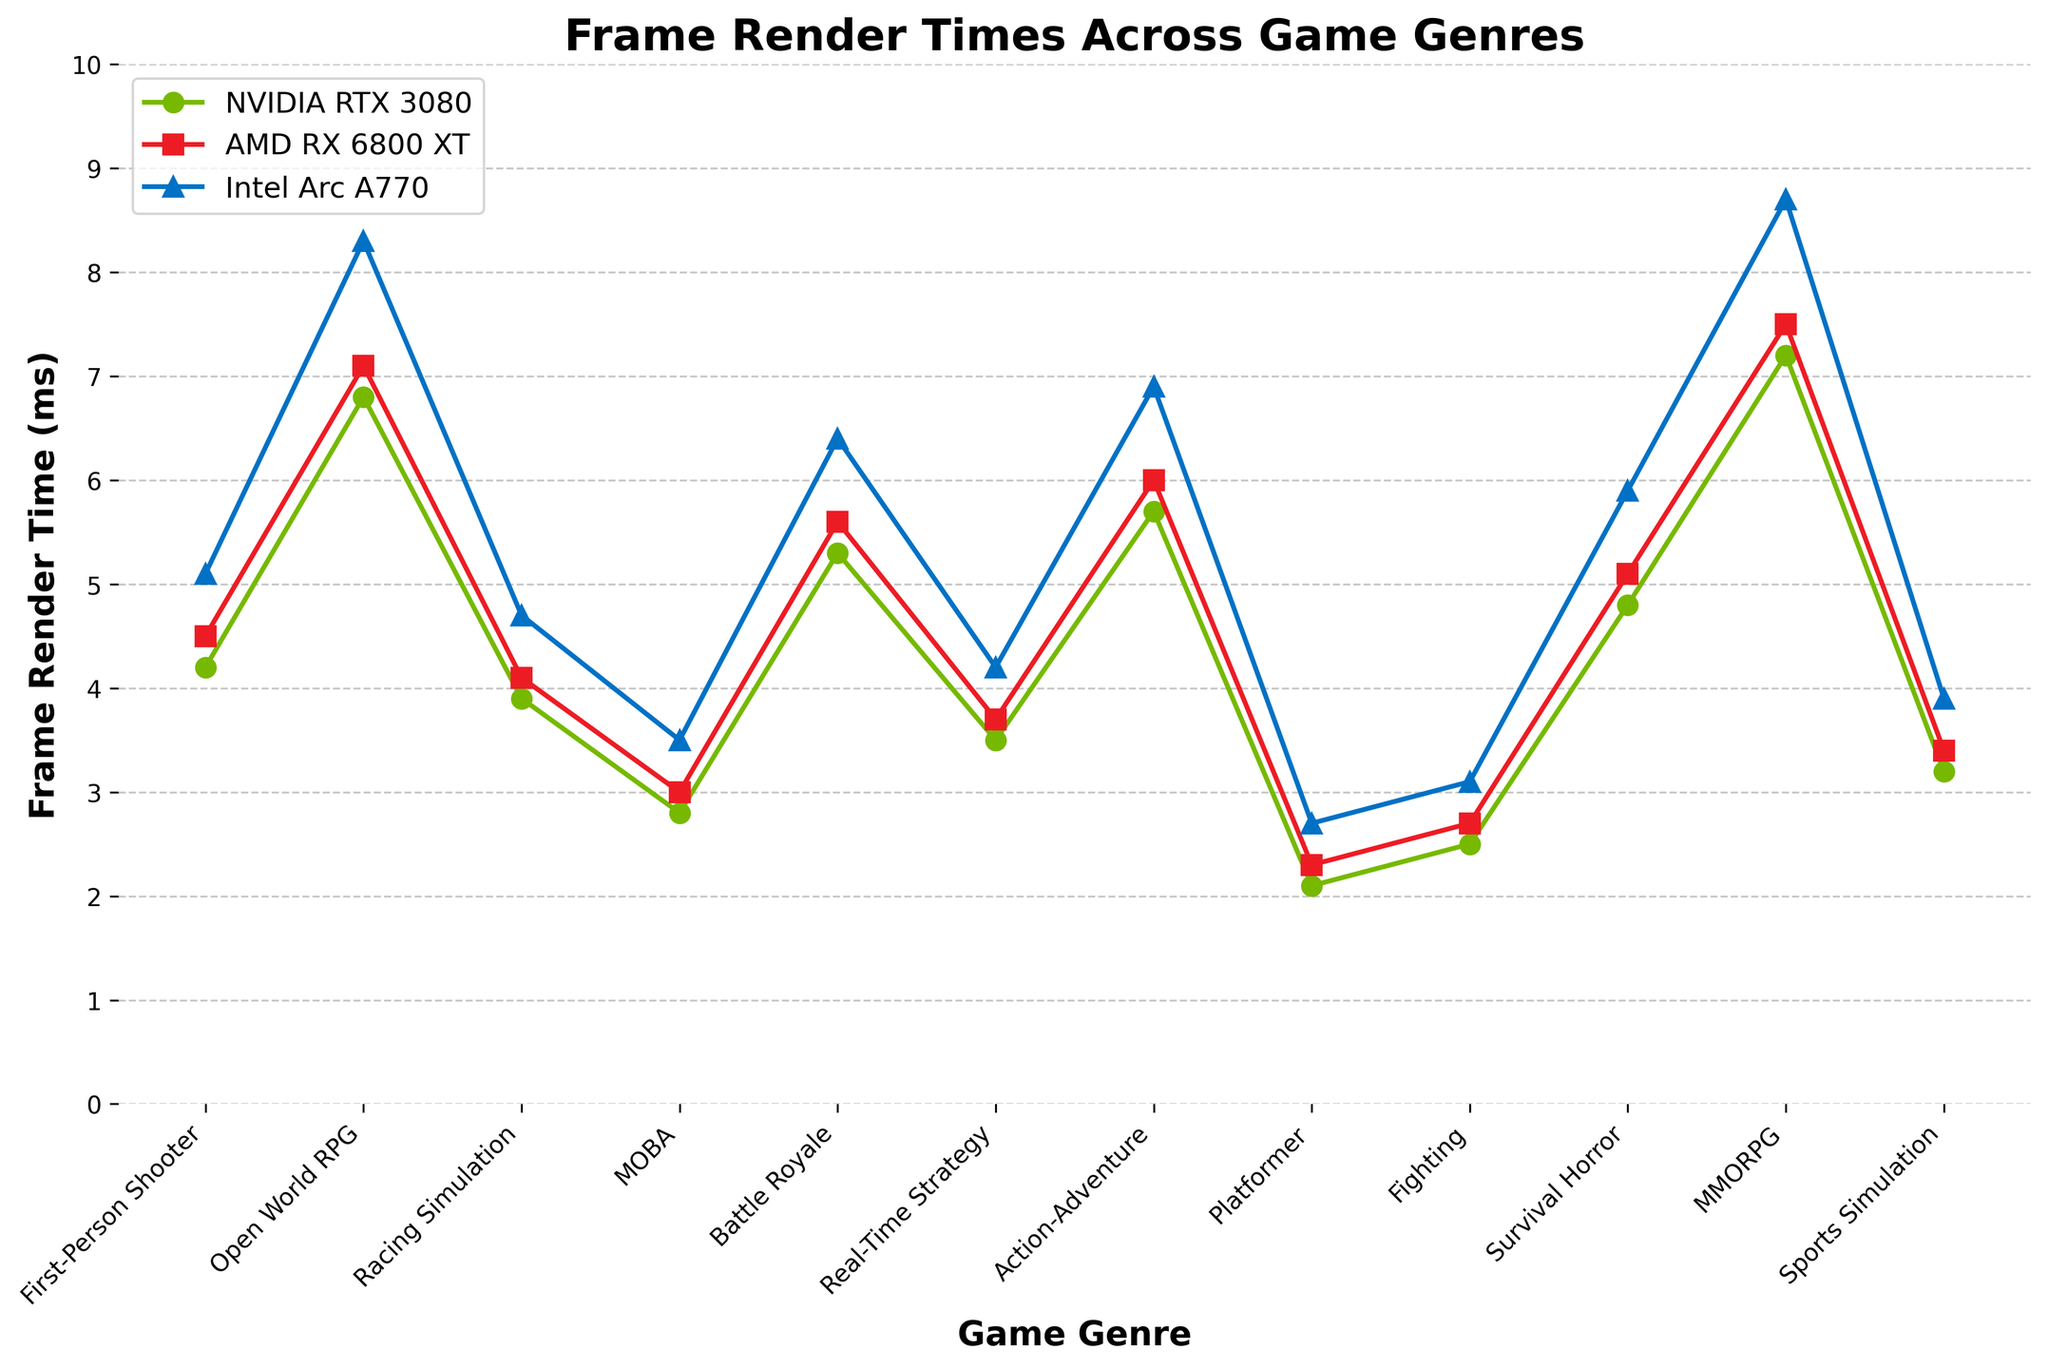which GPU has the lowest frame render time for First-Person Shooter games? By examining the plot, we can see that the NVIDIA RTX 3080 has a frame render time of 4.2 ms for First-Person Shooter games, which is lower than AMD RX 6800 XT (4.5 ms) and Intel Arc A770 (5.1 ms)
Answer: NVIDIA RTX 3080 what is the average frame render time for the Racing Simulation genre across all GPU architectures? The frame render times for Racing Simulation are NVIDIA RTX 3080: 3.9 ms, AMD RX 6800 XT: 4.1 ms, and Intel Arc A770: 4.7 ms. Summing these values gives 3.9 + 4.1 + 4.7 = 12.7 ms, and dividing by 3 gives 12.7 / 3 = 4.23 ms
Answer: 4.23 ms how much greater is the frame render time for MMORPG on the Intel Arc A770 compared to the NVIDIA RTX 3080? The frame render time for MMORPG on the Intel Arc A770 is 8.7 ms, and for the NVIDIA RTX 3080, it is 7.2 ms. The difference is 8.7 - 7.2 = 1.5 ms
Answer: 1.5 ms for which game genre is the frame render time almost equal across all three GPU architectures? By closely examining the plot, we can see that the Racing Simulation genre has frame render times that are quite close for all three GPUs: NVIDIA RTX 3080 (3.9 ms), AMD RX 6800 XT (4.1 ms), and Intel Arc A770 (4.7 ms)
Answer: Racing Simulation which game genre has the highest frame render time overall, and which GPU achieves it? To determine this, we look for the maximum y-axis value on the plot. The MMORPG genre on the Intel Arc A770 has the highest frame render time overall at 8.7 ms
Answer: MMORPG on Intel Arc A770 what is the trend in frame render times from MOBA to Battle Royale for the AMD RX 6800 XT GPU? First, locate the frame render times for the AMD RX 6800 XT for these genres on the plot: MOBA (3.0 ms) and Battle Royale (5.6 ms). Notice that there is an increasing trend in the frame render times from MOBA to Battle Royale
Answer: Increasing how does the frame render time for Survival Horror compare between the NVIDIA RTX 3080 and the AMD RX 6800 XT? The frame render time for Survival Horror is 4.8 ms on the NVIDIA RTX 3080 and 5.1 ms on the AMD RX 6800 XT. Comparing these, the NVIDIA RTX 3080 has a lower frame render time than the AMD RX 6800 XT
Answer: NVIDIA RTX 3080 is lower what is the difference in frame render times between the Action-Adventure and Platformer genres for the Intel Arc A770 GPU? The frame render time for Action-Adventure on the Intel Arc A770 is 6.9 ms, and for Platformer, it is 2.7 ms. The difference is 6.9 - 2.7 = 4.2 ms
Answer: 4.2 ms 